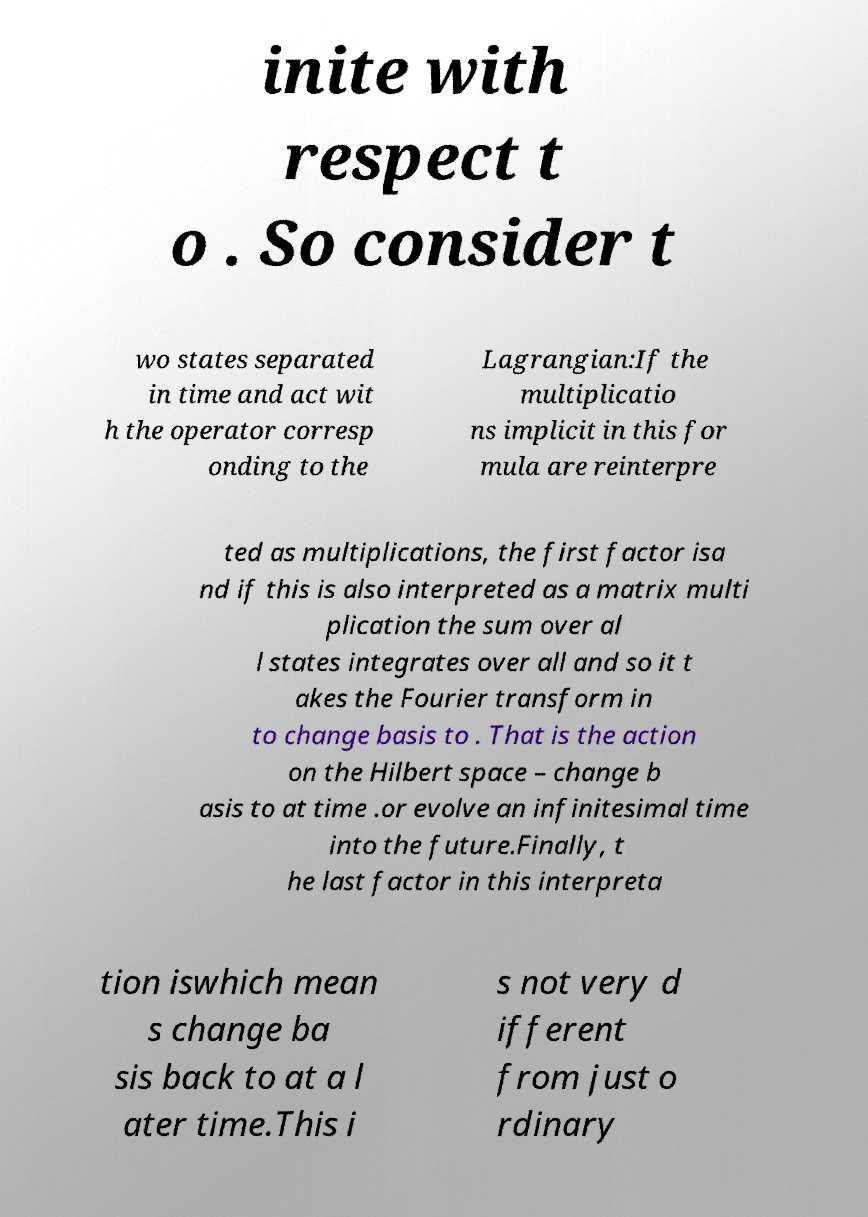Can you read and provide the text displayed in the image?This photo seems to have some interesting text. Can you extract and type it out for me? inite with respect t o . So consider t wo states separated in time and act wit h the operator corresp onding to the Lagrangian:If the multiplicatio ns implicit in this for mula are reinterpre ted as multiplications, the first factor isa nd if this is also interpreted as a matrix multi plication the sum over al l states integrates over all and so it t akes the Fourier transform in to change basis to . That is the action on the Hilbert space – change b asis to at time .or evolve an infinitesimal time into the future.Finally, t he last factor in this interpreta tion iswhich mean s change ba sis back to at a l ater time.This i s not very d ifferent from just o rdinary 